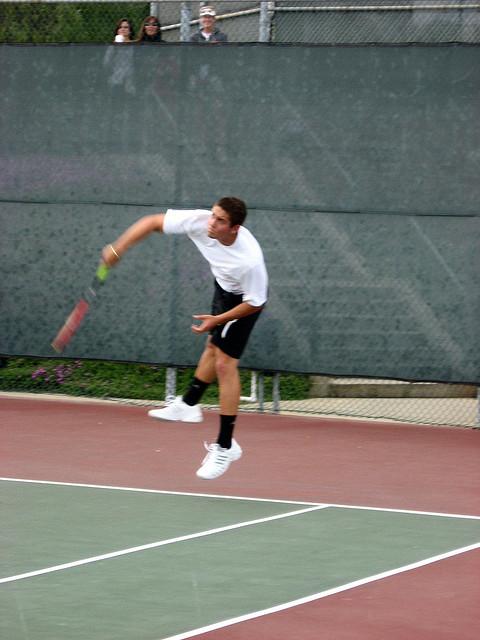Where are the spectators?
Keep it brief. Near stairs. Do the man's sneakers look old?
Be succinct. No. Has he hit the ball?
Concise answer only. Yes. 